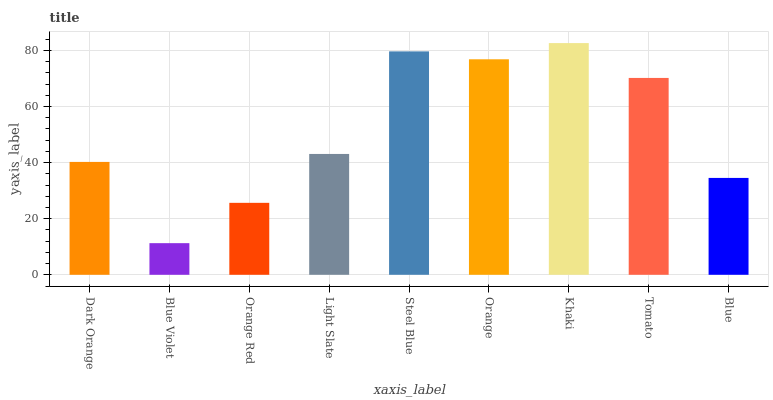Is Blue Violet the minimum?
Answer yes or no. Yes. Is Khaki the maximum?
Answer yes or no. Yes. Is Orange Red the minimum?
Answer yes or no. No. Is Orange Red the maximum?
Answer yes or no. No. Is Orange Red greater than Blue Violet?
Answer yes or no. Yes. Is Blue Violet less than Orange Red?
Answer yes or no. Yes. Is Blue Violet greater than Orange Red?
Answer yes or no. No. Is Orange Red less than Blue Violet?
Answer yes or no. No. Is Light Slate the high median?
Answer yes or no. Yes. Is Light Slate the low median?
Answer yes or no. Yes. Is Khaki the high median?
Answer yes or no. No. Is Steel Blue the low median?
Answer yes or no. No. 